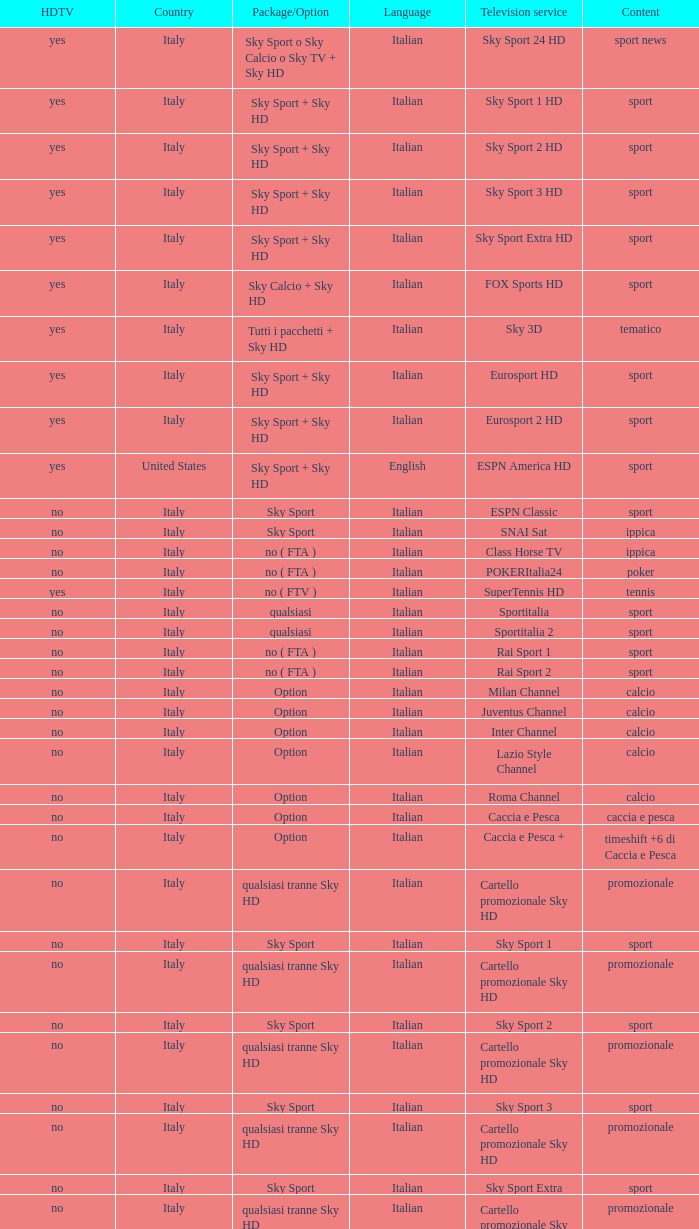What is Package/Option, when Content is Poker? No ( fta ). 